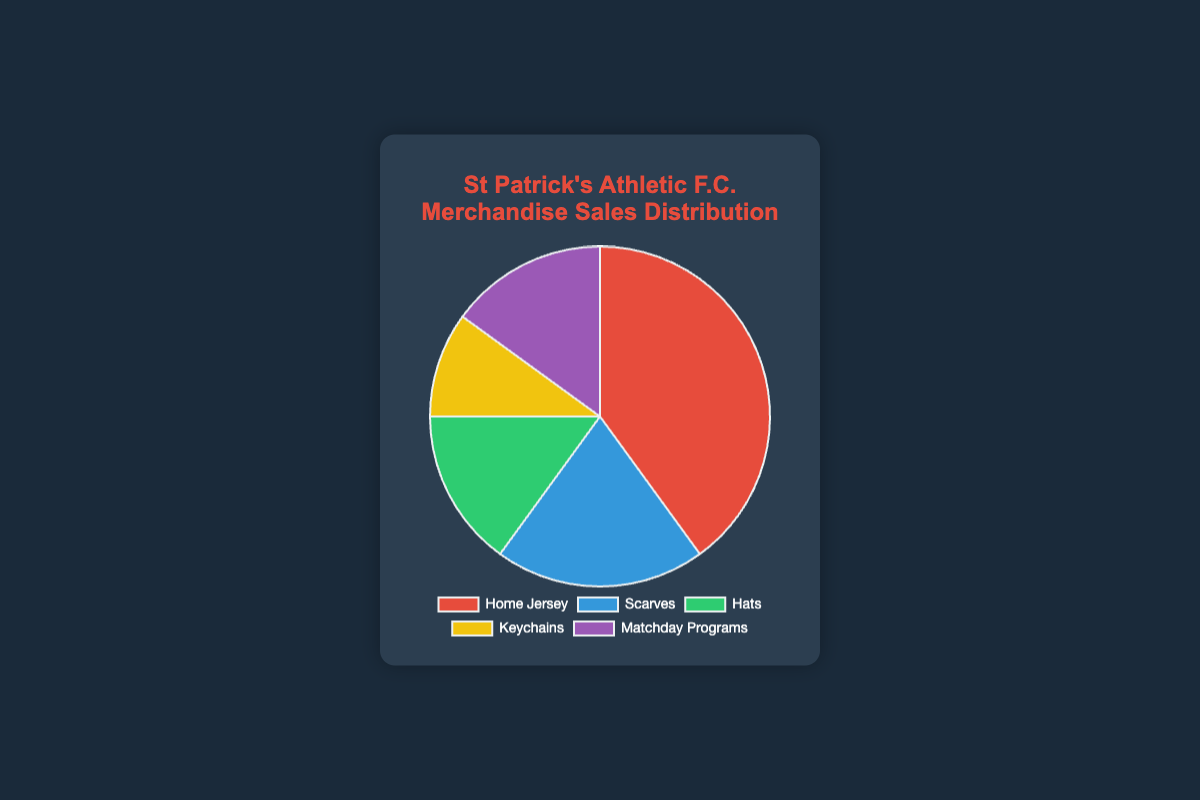What percentage of fans purchased both Hats and Keychains? To find the combined percentage for Hats and Keychains, sum their individual percentages: Hats (15%) + Keychains (10%) = 25%
Answer: 25% Which merchandise type is the least popular among fans? Compare the percentages of all merchandise types: Home Jersey (40%), Scarves (20%), Hats (15%), Keychains (10%), Matchday Programs (15%). The least popular type is the one with the lowest percentage, which is Keychains at 10%
Answer: Keychains How much more popular are Home Jerseys compared to Scarves? Subtract the percentage of Scarves from the percentage of Home Jerseys: 40% (Home Jerseys) - 20% (Scarves) = 20%
Answer: 20% What is the total percentage of fans who purchased Matchday Programs or Scarves? Sum the percentages of Matchday Programs and Scarves: Matchday Programs (15%) + Scarves (20%) = 35%
Answer: 35% Which merchandise type has equal popularity to Hats? Check the percentages for each merchandise type: Home Jersey (40%), Scarves (20%), Hats (15%), Keychains (10%), Matchday Programs (15%). Matchday Programs have the same percentage as Hats, which is 15%
Answer: Matchday Programs Is the percentage of fans purchasing Home Jerseys greater than the combined percentage of those purchasing Hats and Keychains? Compare Home Jerseys (40%) to the sum of Hats and Keychains (15% + 10% = 25%). Yes, 40% is greater than 25%
Answer: Yes What is the average percentage of fans purchasing Keychains and Matchday Programs, rounded to the nearest whole number? Sum the percentages of Keychains and Matchday Programs and then divide by 2: (10% + 15%) / 2 = 12.5%, which rounds to 13%
Answer: 13% Which merchandise type is represented by the blue section of the pie chart? The data lists the colors in order: ['#e74c3c', '#3498db', '#2ecc71', '#f1c40f', '#9b59b6'], which correspond to ['Home Jersey', 'Scarves', 'Hats', 'Keychains', 'Matchday Programs']. The second item is Scarves, which is blue
Answer: Scarves What percentage do Hats and Matchday Programs share, and how does that compare to Scarves alone? Hats (15%) and Matchday Programs (15%) combined make 30%. Compare this to Scarves alone at 20%. The combined percentage (30%) is greater than Scarves alone (20%) by 10%
Answer: Combined: 30%, Difference: 10% 